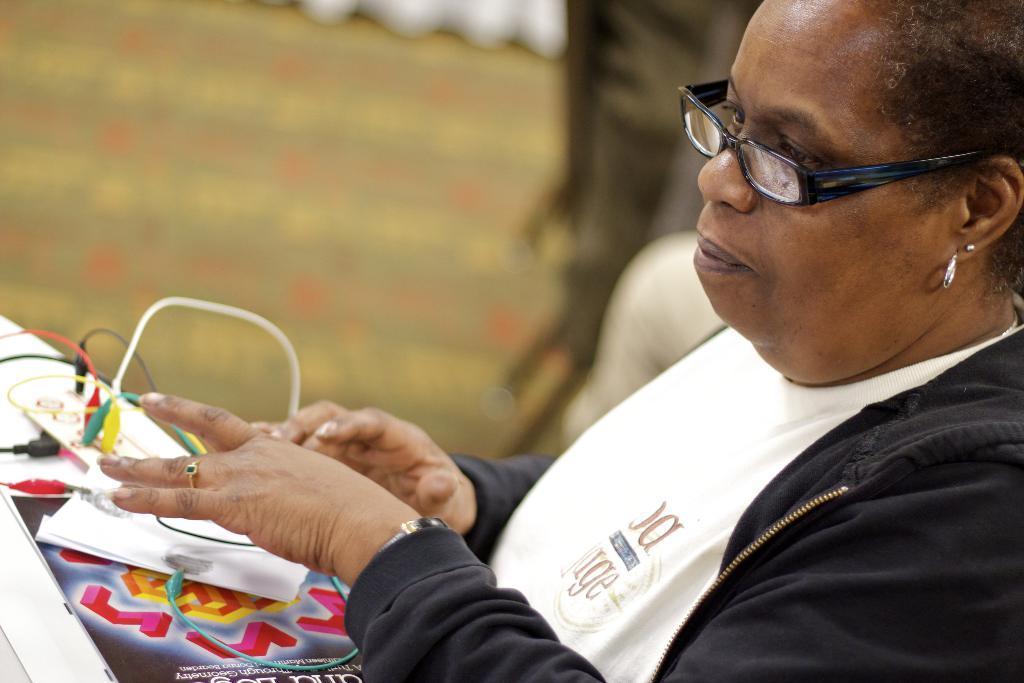Can you describe this image briefly? In the picture I can see a woman on the right side and she is wearing a black color jacket. I can see the adapter cables and a design paper on the left side. 